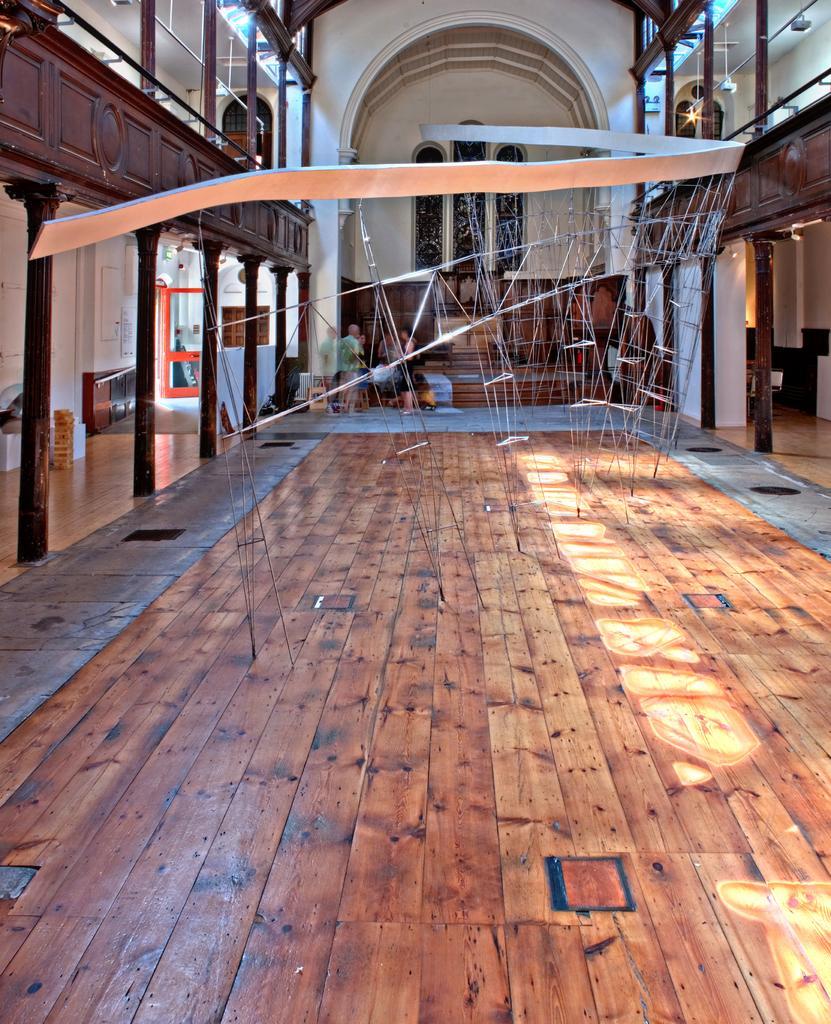Please provide a concise description of this image. In this image we can see the inner view of a building. In the building there are poles, electric lights and persons standing on the floor. 